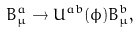<formula> <loc_0><loc_0><loc_500><loc_500>B ^ { a } _ { \mu } \rightarrow U ^ { a b } ( \phi ) B ^ { b } _ { \mu } ,</formula> 